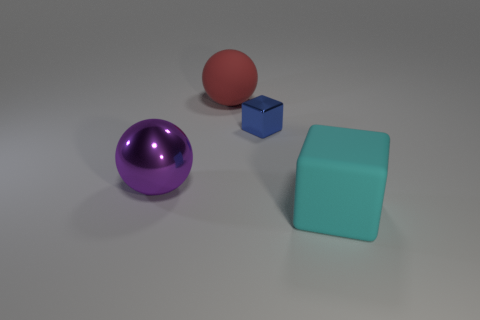What is the purpose of the inclusion of multiple geometric shapes in different colors? The arrangement of multiple geometric shapes in various colors often serves to illustrate principles of geometry, color theory, and spatial relations. Each shape and color might represent different concepts or ideas, making the image a useful educational tool or a piece of visual art that encourages interpretation. 